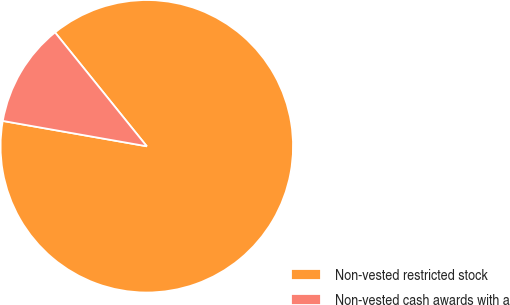Convert chart to OTSL. <chart><loc_0><loc_0><loc_500><loc_500><pie_chart><fcel>Non-vested restricted stock<fcel>Non-vested cash awards with a<nl><fcel>88.57%<fcel>11.43%<nl></chart> 